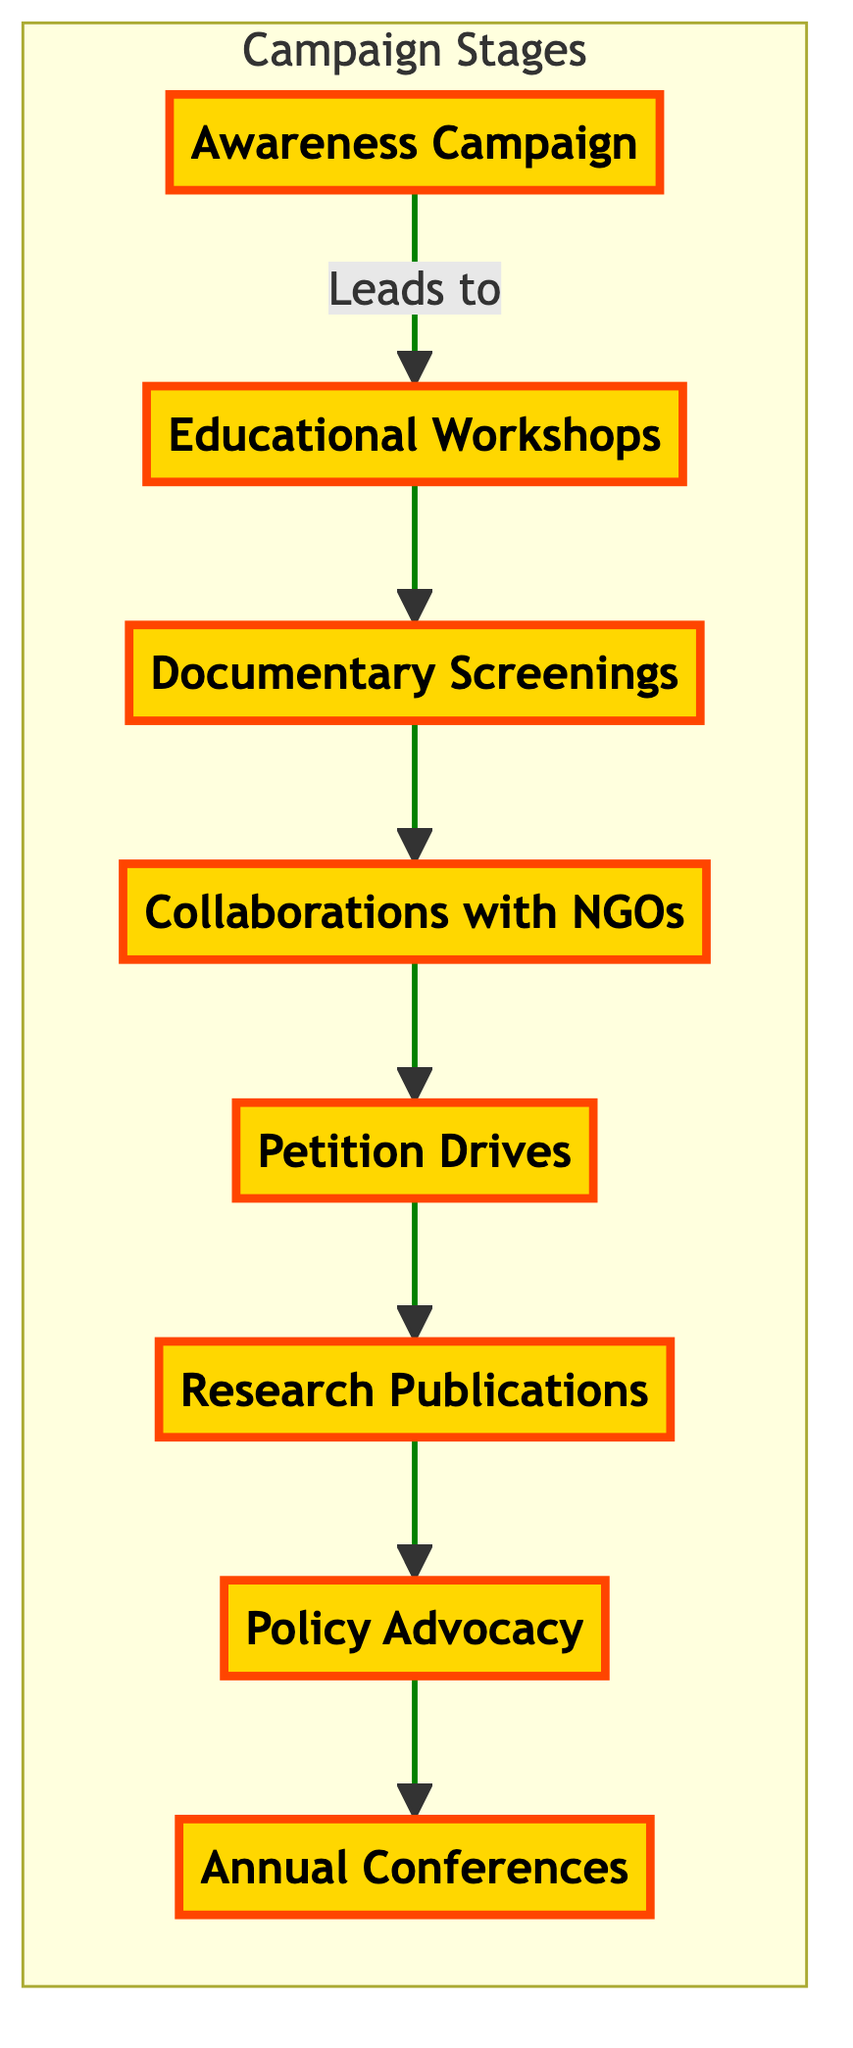What is the first stage of the campaign? The diagram lists "Awareness Campaign" as the starting node, indicating that it is the first stage in the flowchart.
Answer: Awareness Campaign How many stages are there in the campaign? Counting the nodes in the flowchart reveals a total of eight stages from "Awareness Campaign" to "Annual Conferences."
Answer: 8 What follows after Educational Workshops? The flowchart shows that "Educational Workshops" is connected to "Documentary Screenings" as the next stage, indicating that these two are sequentially related.
Answer: Documentary Screenings Which stage comes before Research Publications? By tracing the connections in the diagram, one can see that "Petition Drives" is the stage directly linked before "Research Publications."
Answer: Petition Drives What type of events are organized to raise awareness about Agent Orange effects? "Awareness Campaign" includes social media sharing, TV interviews, and public speeches to educate the public about Agent Orange’s impacts.
Answer: Awareness Campaign How are "Collaborations with NGOs" related to the previous stage? The flowchart indicates that "Collaborations with NGOs" comes after "Documentary Screenings," representing a sequential relationship where screenings likely help to initiate partnerships.
Answer: Flowing into What action is taken after launching petition drives? The diagram shows that after "Petition Drives," the next organized action leads to "Research Publications," indicating a progression after petitions.
Answer: Research Publications Which stage involves engaging with policymakers? According to the diagram, "Policy Advocacy" is dedicated to engaging with policymakers and is the step following "Research Publications."
Answer: Policy Advocacy What is the ultimate goal of the campaign, as suggested by the final stage? "Annual Conferences" suggests a long-term goal of reviewing progress and strategizing future actions among all stakeholders in the campaign.
Answer: Annual Conferences 